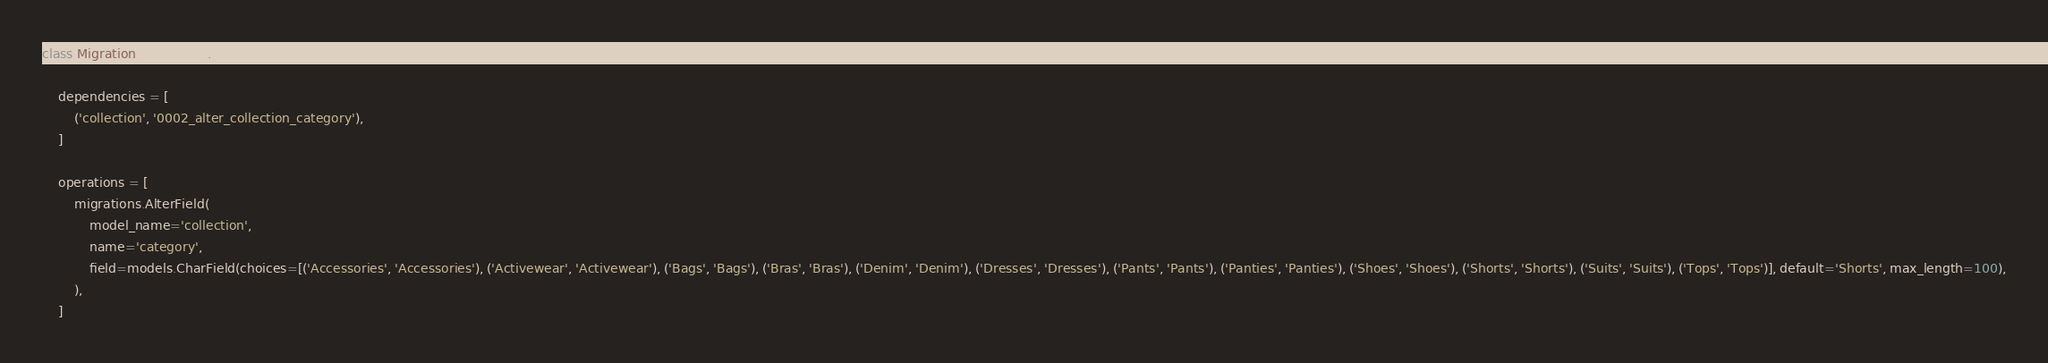<code> <loc_0><loc_0><loc_500><loc_500><_Python_>
class Migration(migrations.Migration):

    dependencies = [
        ('collection', '0002_alter_collection_category'),
    ]

    operations = [
        migrations.AlterField(
            model_name='collection',
            name='category',
            field=models.CharField(choices=[('Accessories', 'Accessories'), ('Activewear', 'Activewear'), ('Bags', 'Bags'), ('Bras', 'Bras'), ('Denim', 'Denim'), ('Dresses', 'Dresses'), ('Pants', 'Pants'), ('Panties', 'Panties'), ('Shoes', 'Shoes'), ('Shorts', 'Shorts'), ('Suits', 'Suits'), ('Tops', 'Tops')], default='Shorts', max_length=100),
        ),
    ]
</code> 